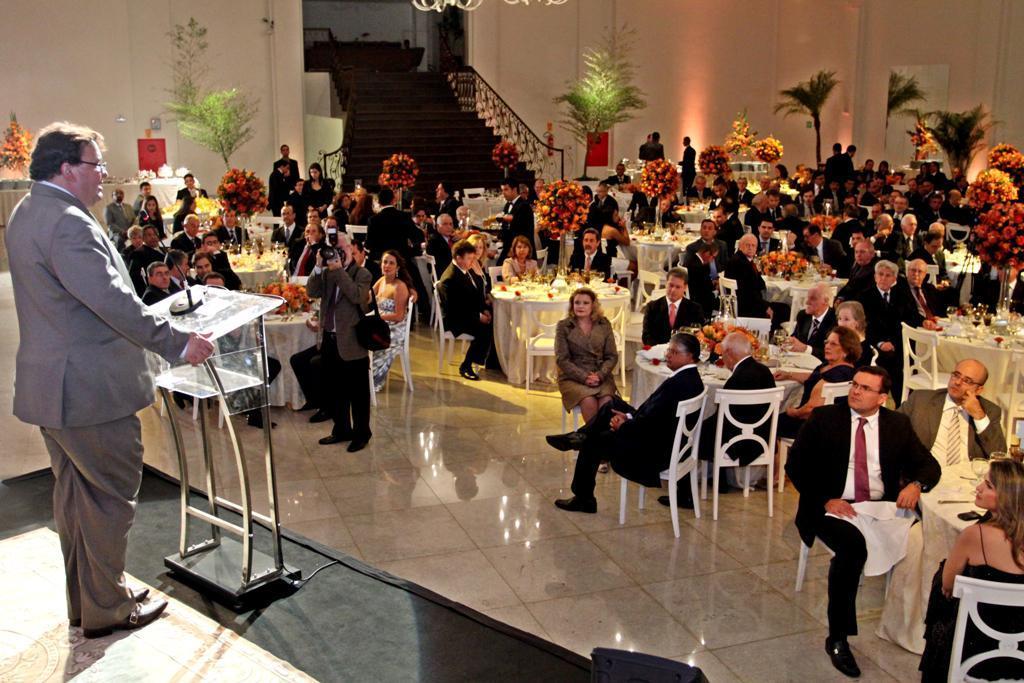Can you describe this image briefly? In this image there are group of people sitting around the table on which we can see there are glasses and some flower vases and there is a man standing on the stage in front of table, behind the crowd there are so many stairs and some plants. 